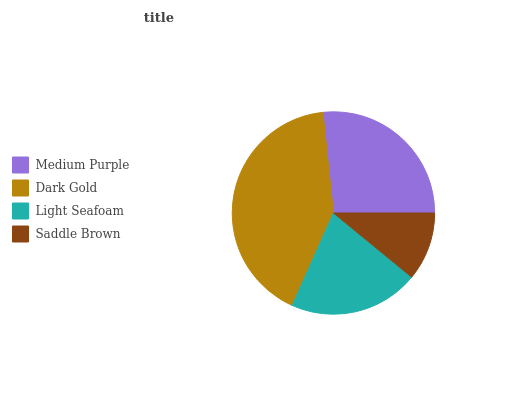Is Saddle Brown the minimum?
Answer yes or no. Yes. Is Dark Gold the maximum?
Answer yes or no. Yes. Is Light Seafoam the minimum?
Answer yes or no. No. Is Light Seafoam the maximum?
Answer yes or no. No. Is Dark Gold greater than Light Seafoam?
Answer yes or no. Yes. Is Light Seafoam less than Dark Gold?
Answer yes or no. Yes. Is Light Seafoam greater than Dark Gold?
Answer yes or no. No. Is Dark Gold less than Light Seafoam?
Answer yes or no. No. Is Medium Purple the high median?
Answer yes or no. Yes. Is Light Seafoam the low median?
Answer yes or no. Yes. Is Dark Gold the high median?
Answer yes or no. No. Is Medium Purple the low median?
Answer yes or no. No. 